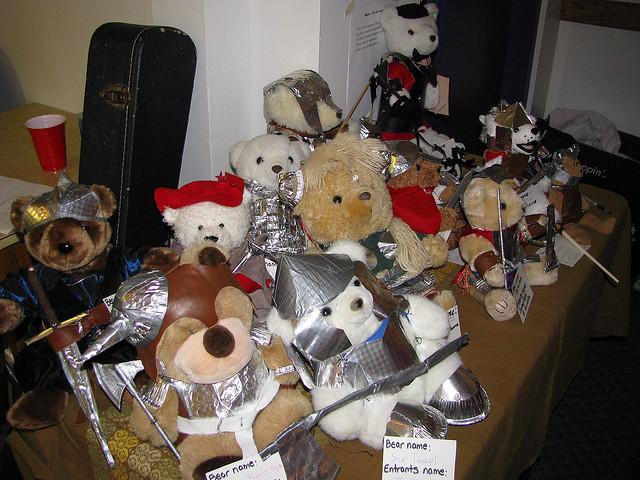What stuffed toys are these animals?
Quick response, please. Teddy bears. What season are these items meant to be used in?
Quick response, please. Winter. Is this in a store?
Short answer required. No. 